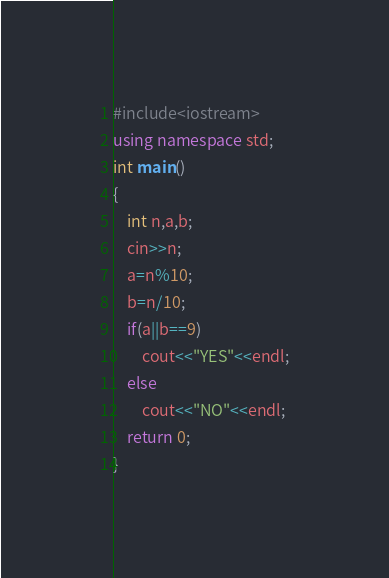<code> <loc_0><loc_0><loc_500><loc_500><_C++_>#include<iostream>
using namespace std;
int main()
{
    int n,a,b;
    cin>>n;
    a=n%10;
    b=n/10;
    if(a||b==9)
        cout<<"YES"<<endl;
    else
        cout<<"NO"<<endl;
    return 0;
}</code> 